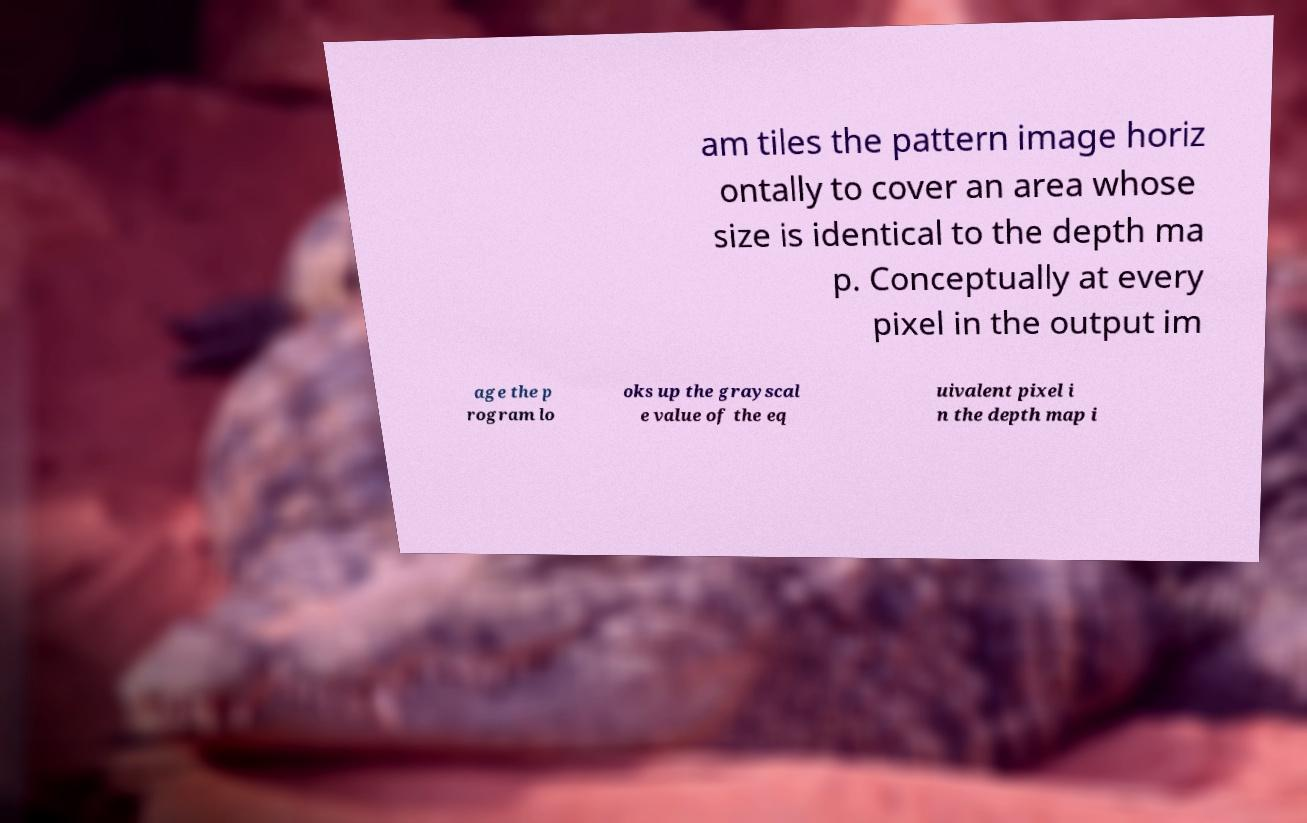Could you extract and type out the text from this image? am tiles the pattern image horiz ontally to cover an area whose size is identical to the depth ma p. Conceptually at every pixel in the output im age the p rogram lo oks up the grayscal e value of the eq uivalent pixel i n the depth map i 